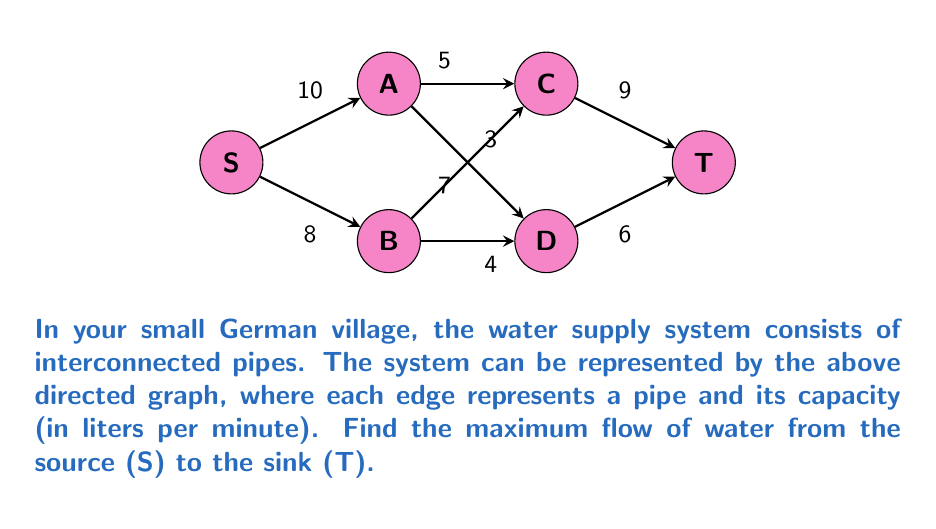Give your solution to this math problem. To find the maximum flow in this network, we can use the Ford-Fulkerson algorithm:

1) Initialize all flows to 0.

2) Find an augmenting path from S to T. Let's use path S-A-C-T:
   $$\text{Min}(10, 5, 9) = 5$$
   Update flows:
   S-A: 5, A-C: 5, C-T: 5

3) Find another augmenting path. Let's use S-A-D-T:
   $$\text{Min}(10-5, 7, 6) = 5$$
   Update flows:
   S-A: 10, A-D: 5, D-T: 5

4) Find another augmenting path. Use S-B-D-T:
   $$\text{Min}(8, 4, 6-5) = 1$$
   Update flows:
   S-B: 1, B-D: 1, D-T: 6

5) Find another augmenting path. Use S-B-C-T:
   $$\text{Min}(8-1, 3, 9-5) = 3$$
   Update flows:
   S-B: 4, B-C: 3, C-T: 8

6) No more augmenting paths exist.

The maximum flow is the sum of flows leaving the source S:
$$10 + 4 = 14$$

Or equivalently, the sum of flows entering the sink T:
$$8 + 6 = 14$$
Answer: 14 liters per minute 